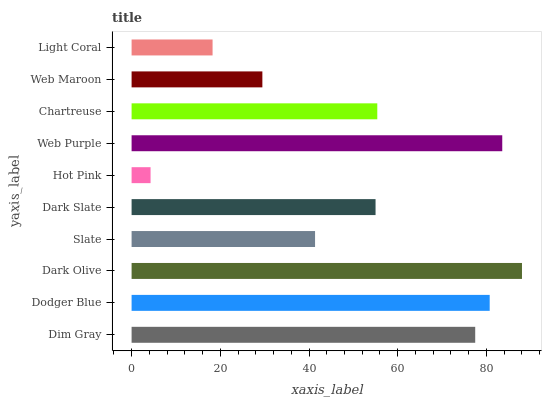Is Hot Pink the minimum?
Answer yes or no. Yes. Is Dark Olive the maximum?
Answer yes or no. Yes. Is Dodger Blue the minimum?
Answer yes or no. No. Is Dodger Blue the maximum?
Answer yes or no. No. Is Dodger Blue greater than Dim Gray?
Answer yes or no. Yes. Is Dim Gray less than Dodger Blue?
Answer yes or no. Yes. Is Dim Gray greater than Dodger Blue?
Answer yes or no. No. Is Dodger Blue less than Dim Gray?
Answer yes or no. No. Is Chartreuse the high median?
Answer yes or no. Yes. Is Dark Slate the low median?
Answer yes or no. Yes. Is Hot Pink the high median?
Answer yes or no. No. Is Web Maroon the low median?
Answer yes or no. No. 